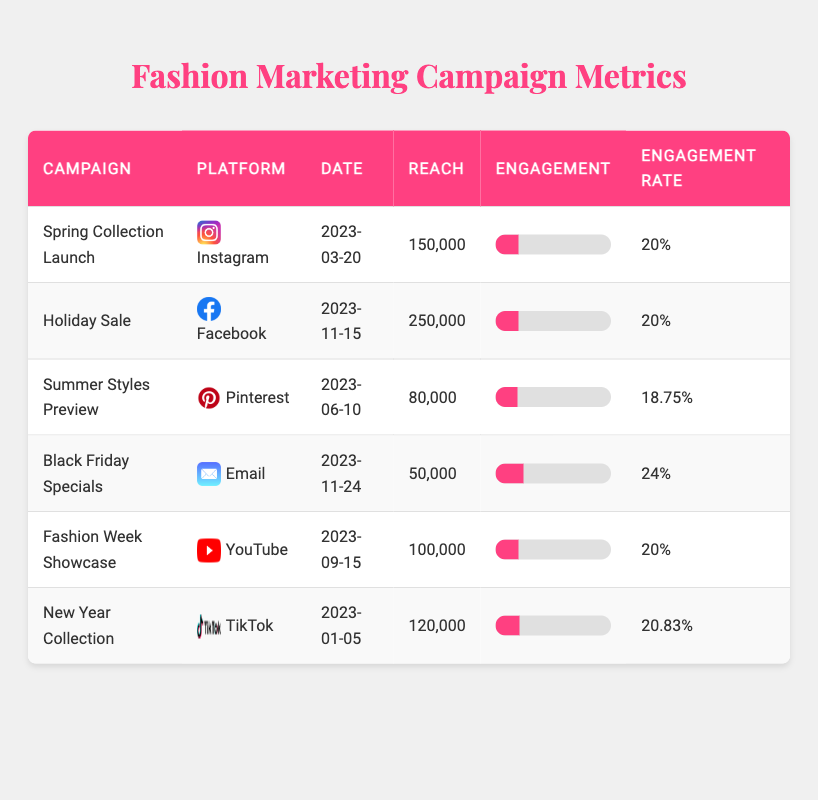What is the reach of the "Summer Styles Preview" campaign? The table lists the reach of the "Summer Styles Preview" campaign as 80,000.
Answer: 80,000 Which campaign had the highest engagement? By reviewing the engagement column, the "Holiday Sale" campaign shows the highest engagement at 50,000.
Answer: Holiday Sale How many likes did the "Black Friday Specials" campaign receive? The table indicates that the "Black Friday Specials" campaign received 0 likes.
Answer: 0 What is the total reach of all campaigns? Adding the reach of all campaigns: 150,000 + 250,000 + 80,000 + 50,000 + 100,000 + 120,000 = 750,000.
Answer: 750,000 What is the average engagement rate across all campaigns? The engagement rates are 20%, 20%, 18.75%, 24%, 20%, and 20.83%. The average engagement rate is (20 + 20 + 18.75 + 24 + 20 + 20.83) / 6 = 20.36%.
Answer: 20.36% Did the "Fashion Week Showcase" campaign get more reach than the "Spring Collection Launch"? The reach for "Fashion Week Showcase" is 100,000, compared to the "Spring Collection Launch" which is 150,000, making it false that it had more reach.
Answer: No Which platform had the least reach? Looking through the reach of each campaign, the "Black Friday Specials" on Email had the least reach at 50,000.
Answer: Email What is the engagement percentage of the "New Year Collection" campaign? The table states that the engagement for the "New Year Collection" campaign is 25,000, while the reach is 120,000. Therefore, the engagement rate = (25,000 / 120,000) * 100 = 20.83%.
Answer: 20.83% Which campaign had the most shares? From the shares column, the "Holiday Sale" campaign and the "Black Friday Specials" both had 2,000 shares, but no other campaign surpassed it. Therefore, it has the maximum.
Answer: Holiday Sale & Black Friday Specials How do the likes of the "Summer Styles Preview" compare to the "New Year Collection"? The "Summer Styles Preview" received 12,000 likes, and the "New Year Collection" received 20,000 likes, meaning the latter campaign had more likes.
Answer: New Year Collection had more likes What is the overall engagement (likes + comments + shares) for the "Spring Collection Launch"? The engagement for the "Spring Collection Launch" includes likes (25,000), comments (3,000), and shares (2,000). Total engagement = 25,000 + 3,000 + 2,000 = 30,000.
Answer: 30,000 